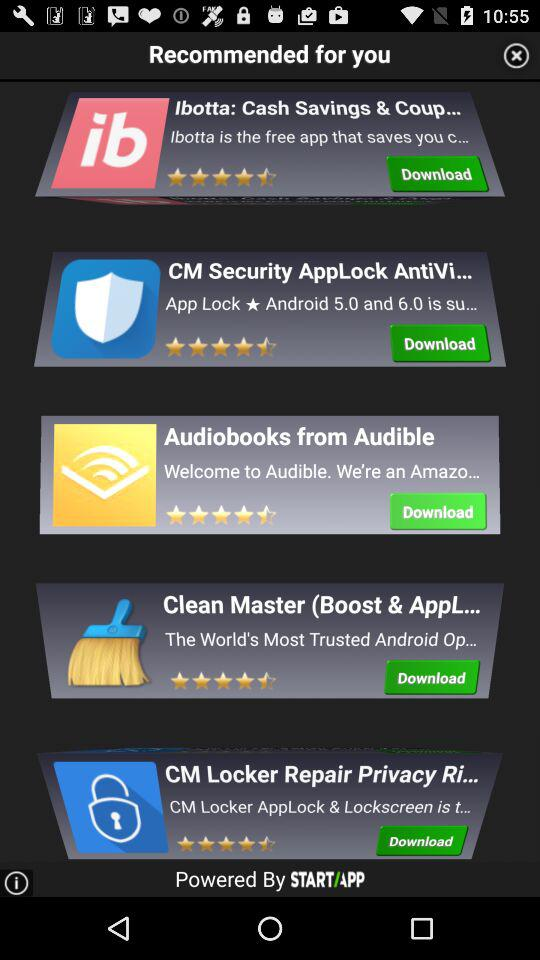What is the star rating for the application "Clean Master (Boost & AppL..."? The rating for the application "Clean Master (Boost & AppL..." is 4.5 stars. 